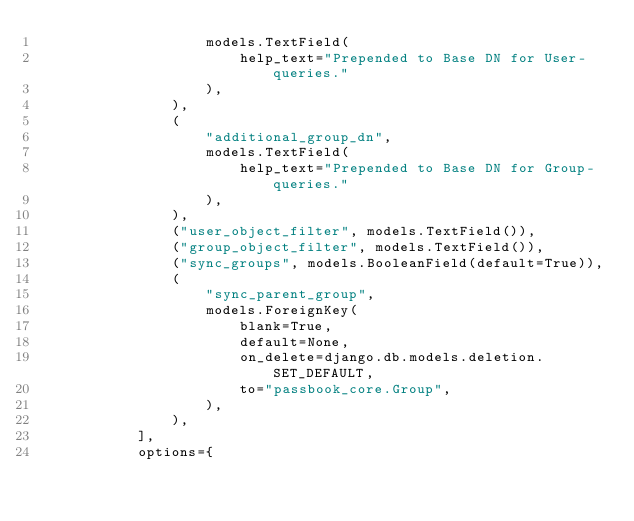<code> <loc_0><loc_0><loc_500><loc_500><_Python_>                    models.TextField(
                        help_text="Prepended to Base DN for User-queries."
                    ),
                ),
                (
                    "additional_group_dn",
                    models.TextField(
                        help_text="Prepended to Base DN for Group-queries."
                    ),
                ),
                ("user_object_filter", models.TextField()),
                ("group_object_filter", models.TextField()),
                ("sync_groups", models.BooleanField(default=True)),
                (
                    "sync_parent_group",
                    models.ForeignKey(
                        blank=True,
                        default=None,
                        on_delete=django.db.models.deletion.SET_DEFAULT,
                        to="passbook_core.Group",
                    ),
                ),
            ],
            options={</code> 